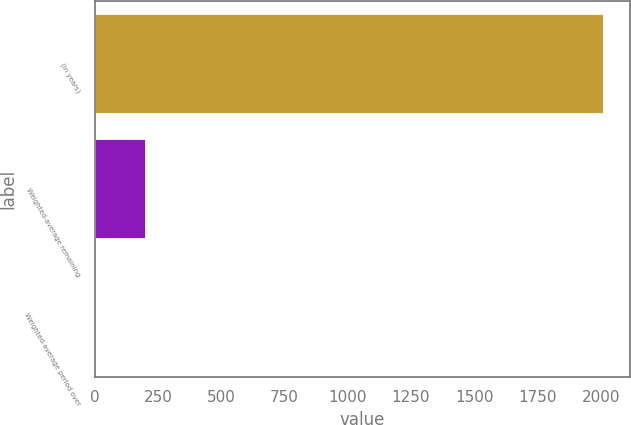<chart> <loc_0><loc_0><loc_500><loc_500><bar_chart><fcel>(in years)<fcel>Weighted-average remaining<fcel>Weighted-average period over<nl><fcel>2013<fcel>203.1<fcel>2<nl></chart> 